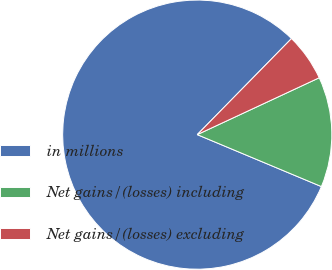<chart> <loc_0><loc_0><loc_500><loc_500><pie_chart><fcel>in millions<fcel>Net gains/(losses) including<fcel>Net gains/(losses) excluding<nl><fcel>81.04%<fcel>13.25%<fcel>5.71%<nl></chart> 